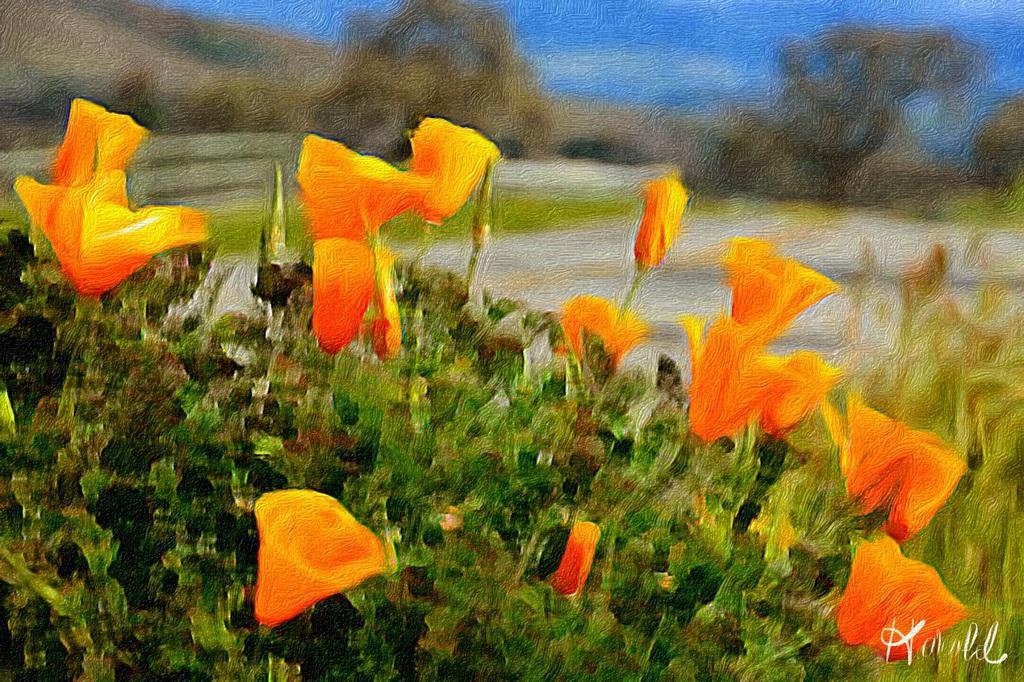How would you summarize this image in a sentence or two? In this image I can see the flowers to the plants. These flowers are in yellow and orange color. In the background I can see the ground and blue sky but it is blurry. 